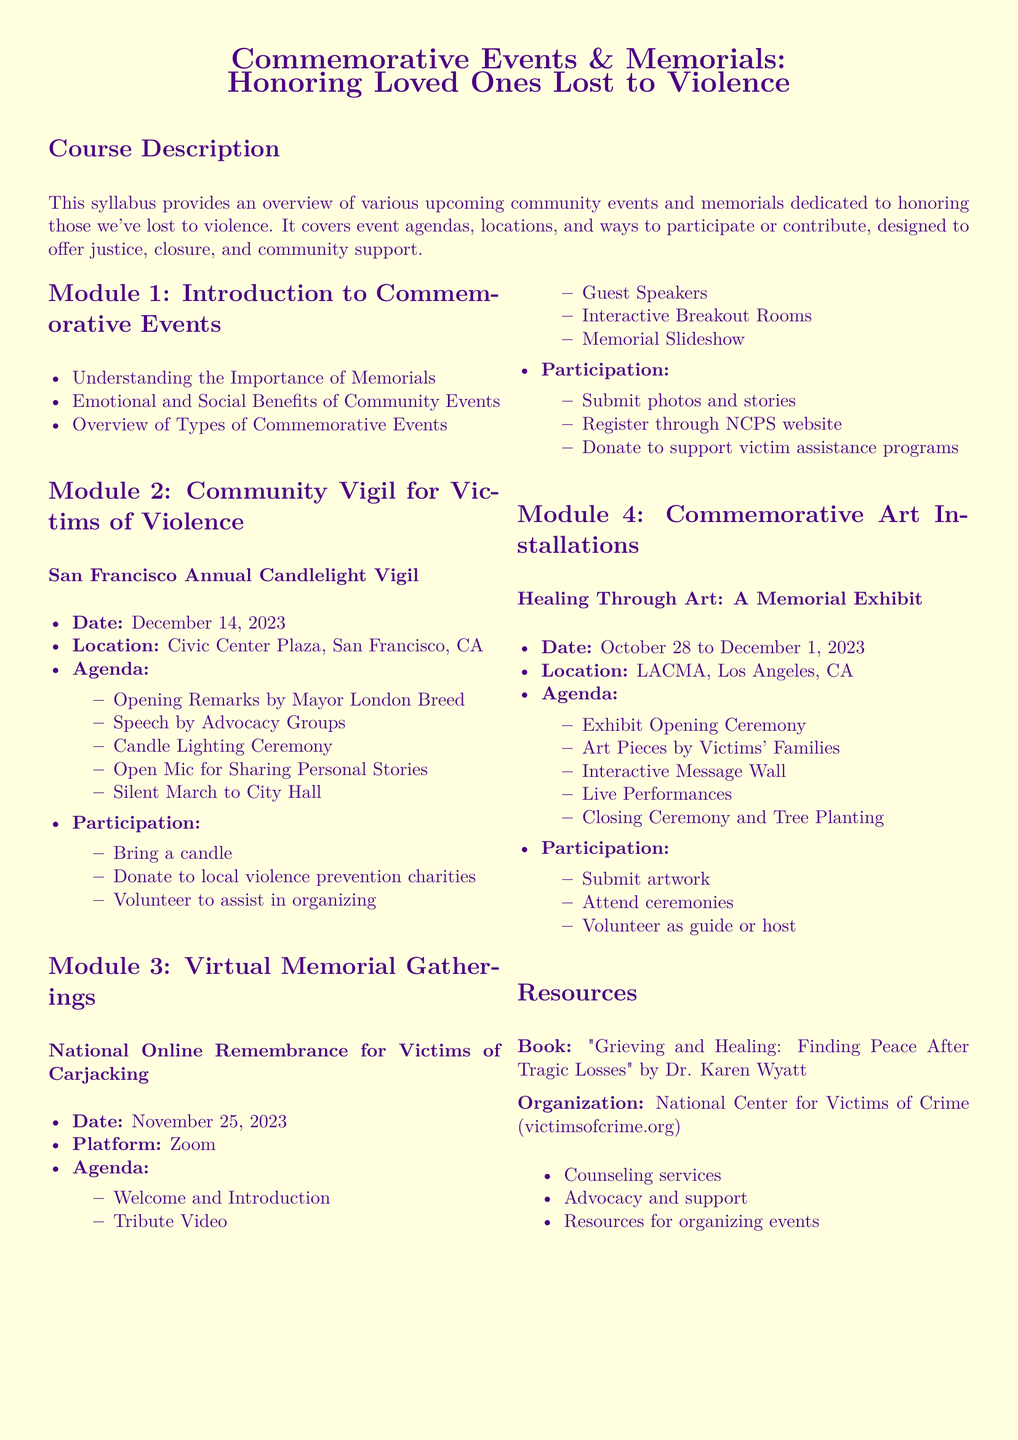What is the date of the San Francisco Annual Candlelight Vigil? The date of the San Francisco Annual Candlelight Vigil is explicitly mentioned in the document.
Answer: December 14, 2023 What is the location of the Healing Through Art: A Memorial Exhibit? The location is provided in the section detailing the exhibit.
Answer: LACMA, Los Angeles, CA Who will provide the opening remarks at the Candlelight Vigil? The document specifies who will give the opening remarks during the event.
Answer: Mayor London Breed What is one way to participate in the National Online Remembrance for Victims of Carjacking? The document includes ways to participate, and one is highlighted for the online event.
Answer: Submit photos and stories What is the duration of the Healing Through Art: A Memorial Exhibit? The duration of the exhibit is clearly stated in the document.
Answer: October 28 to December 1, 2023 What topic does Module 1 cover? The topic for Module 1 is indicated in the syllabus.
Answer: Introduction to Commemorative Events How many modules are there in the syllabus? The total number of modules can be counted from the document's structure.
Answer: Four What is the name of the book listed in the resources? The document specifies the title of the book available in the resources section.
Answer: "Grieving and Healing: Finding Peace After Tragic Losses" by Dr. Karen Wyatt 